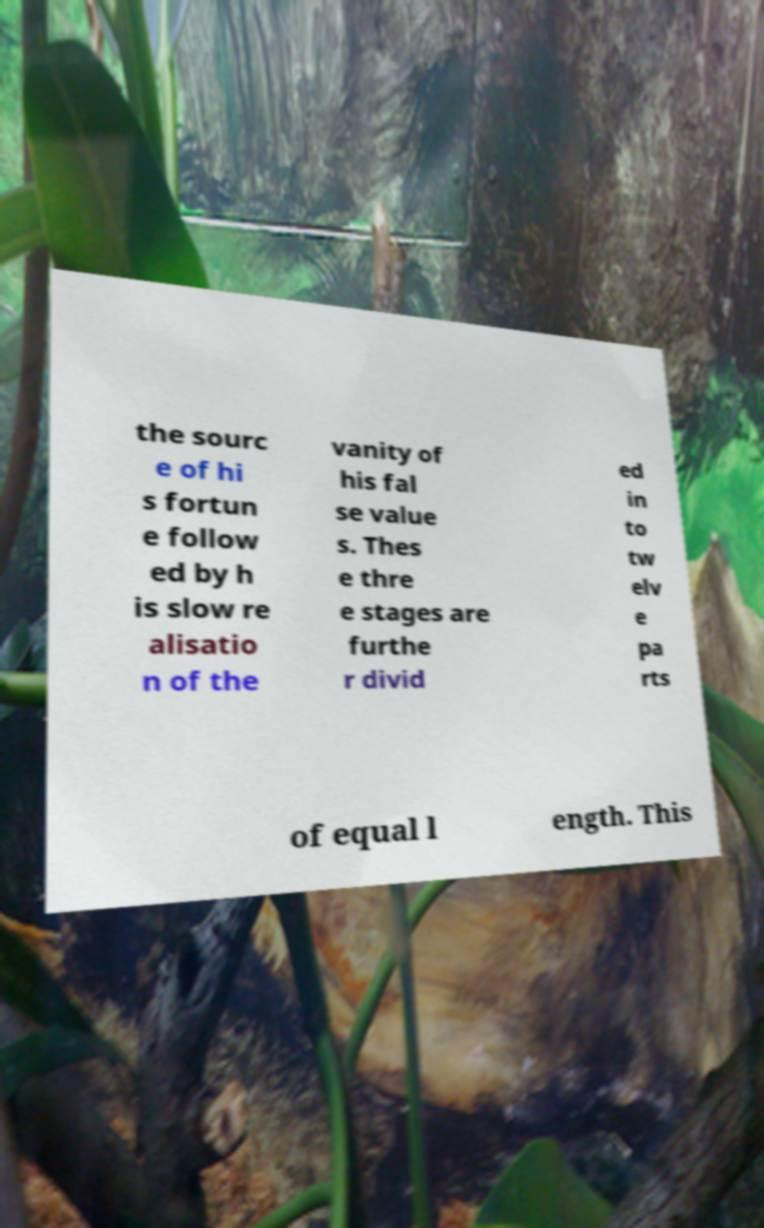What messages or text are displayed in this image? I need them in a readable, typed format. the sourc e of hi s fortun e follow ed by h is slow re alisatio n of the vanity of his fal se value s. Thes e thre e stages are furthe r divid ed in to tw elv e pa rts of equal l ength. This 